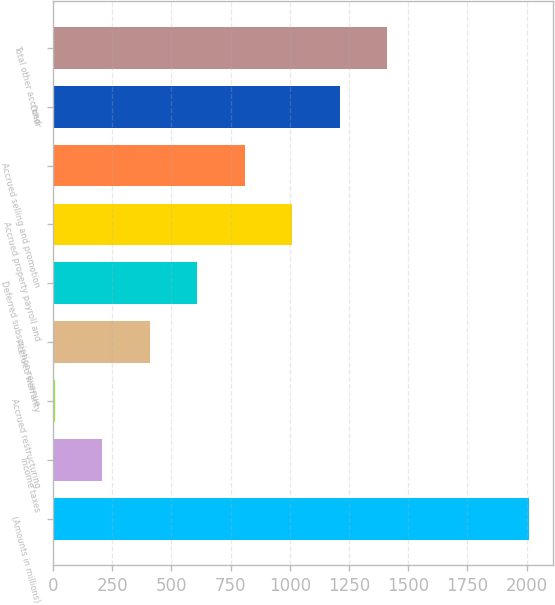<chart> <loc_0><loc_0><loc_500><loc_500><bar_chart><fcel>(Amounts in millions)<fcel>Income taxes<fcel>Accrued restructuring<fcel>Accrued warranty<fcel>Deferred subscription revenue<fcel>Accrued property payroll and<fcel>Accrued selling and promotion<fcel>Other<fcel>Total other accrued<nl><fcel>2011<fcel>208.66<fcel>8.4<fcel>408.92<fcel>609.18<fcel>1009.7<fcel>809.44<fcel>1209.96<fcel>1410.22<nl></chart> 